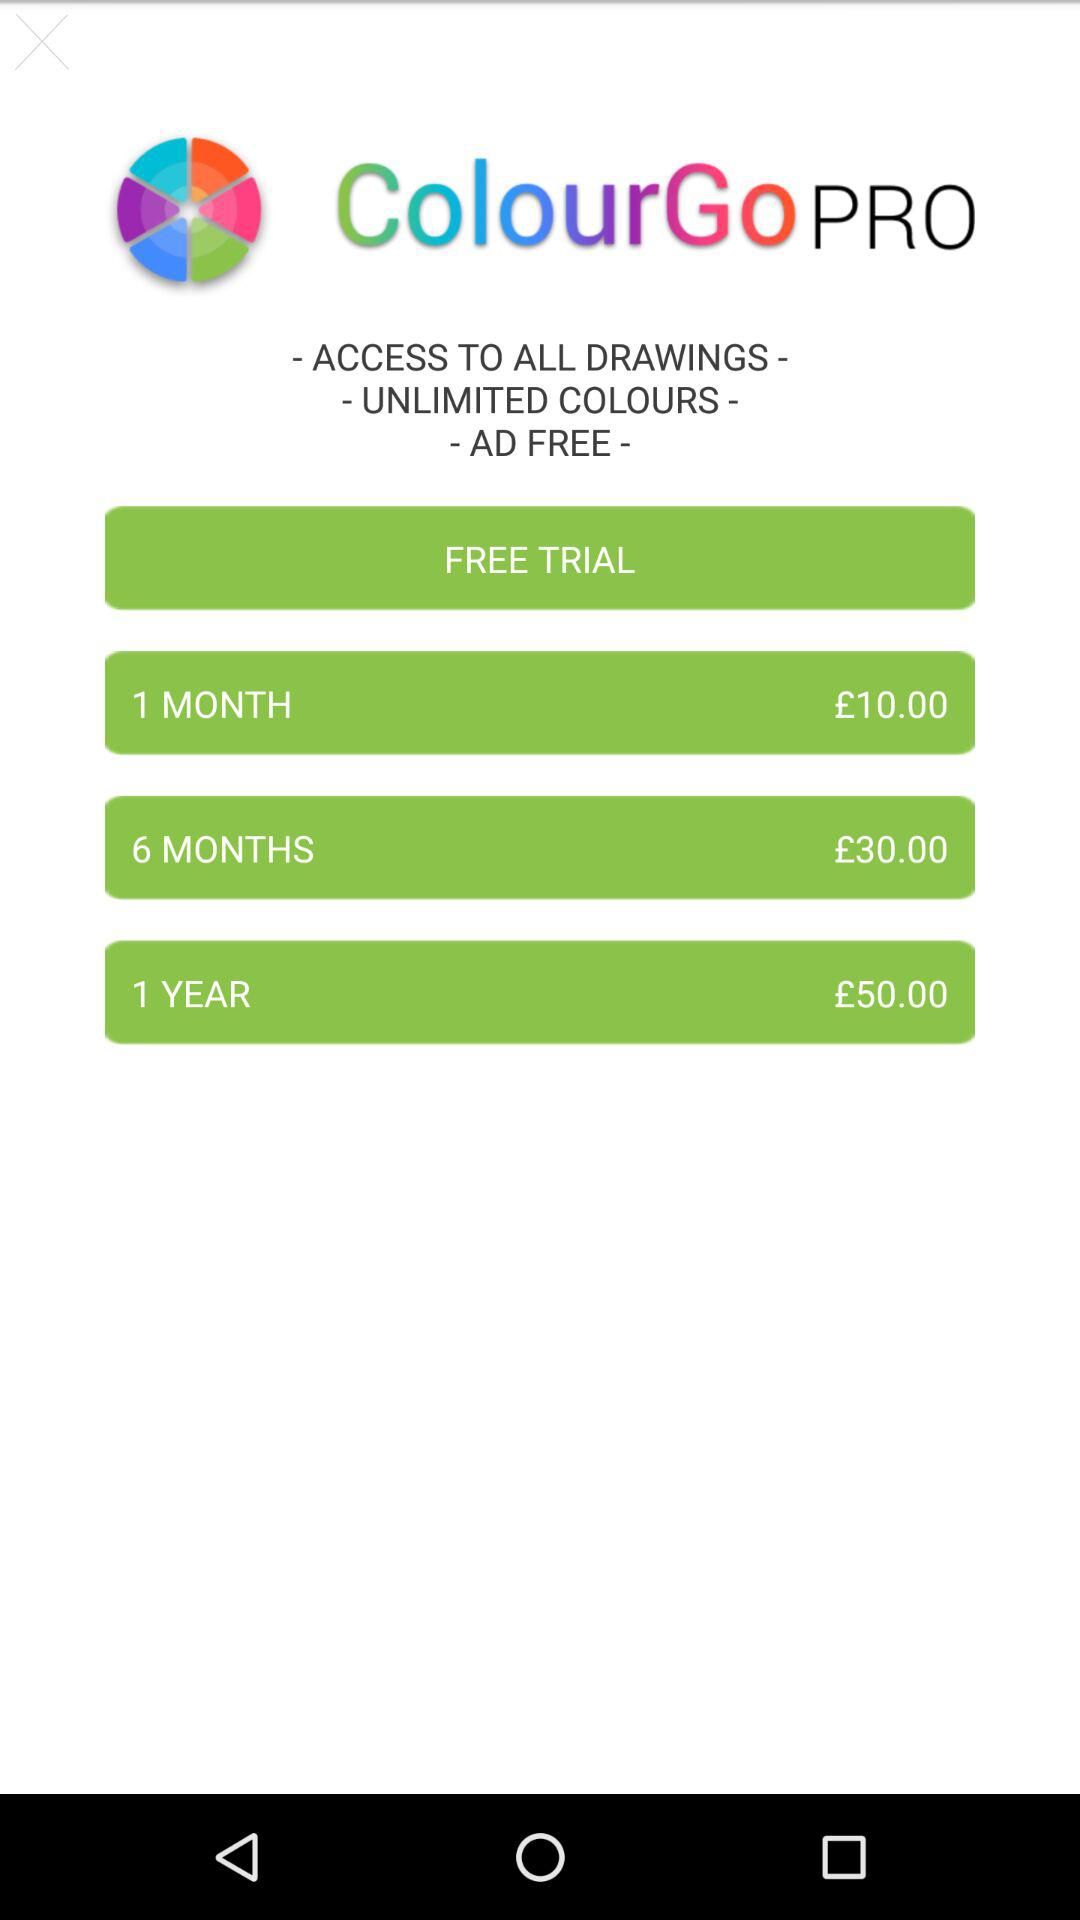What is the application name? The application name is "ColourGo". 